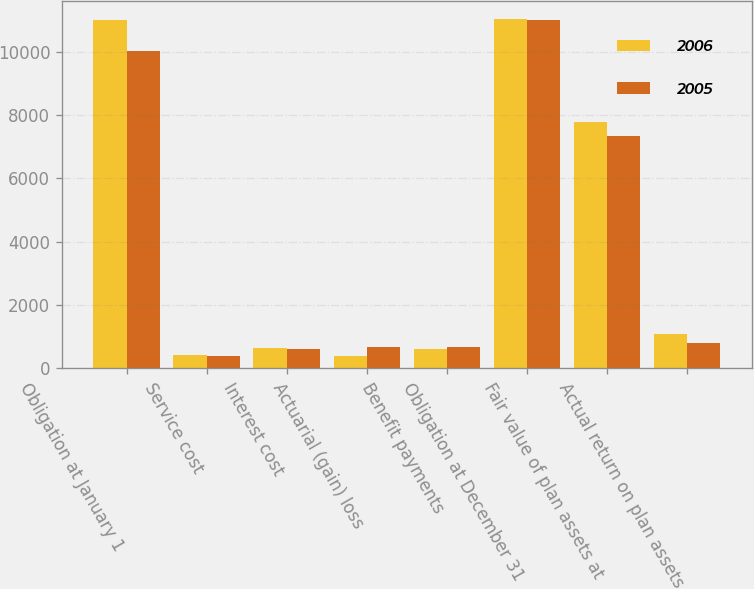Convert chart. <chart><loc_0><loc_0><loc_500><loc_500><stacked_bar_chart><ecel><fcel>Obligation at January 1<fcel>Service cost<fcel>Interest cost<fcel>Actuarial (gain) loss<fcel>Benefit payments<fcel>Obligation at December 31<fcel>Fair value of plan assets at<fcel>Actual return on plan assets<nl><fcel>2006<fcel>11003<fcel>399<fcel>641<fcel>390<fcel>605<fcel>11048<fcel>7778<fcel>1063<nl><fcel>2005<fcel>10022<fcel>372<fcel>611<fcel>649<fcel>651<fcel>11003<fcel>7335<fcel>779<nl></chart> 